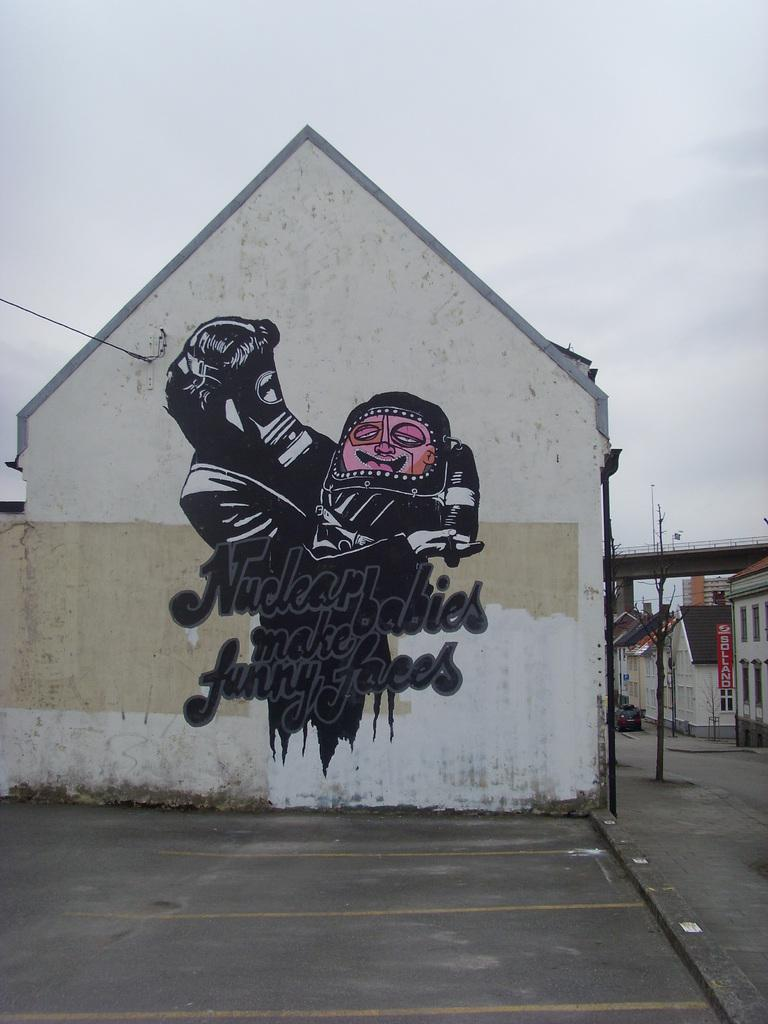<image>
Present a compact description of the photo's key features. A painting on the side of a building depicts a person wearing a gas mask holding a deformed baby with the annotation "Nuclear babies make funny faces." 